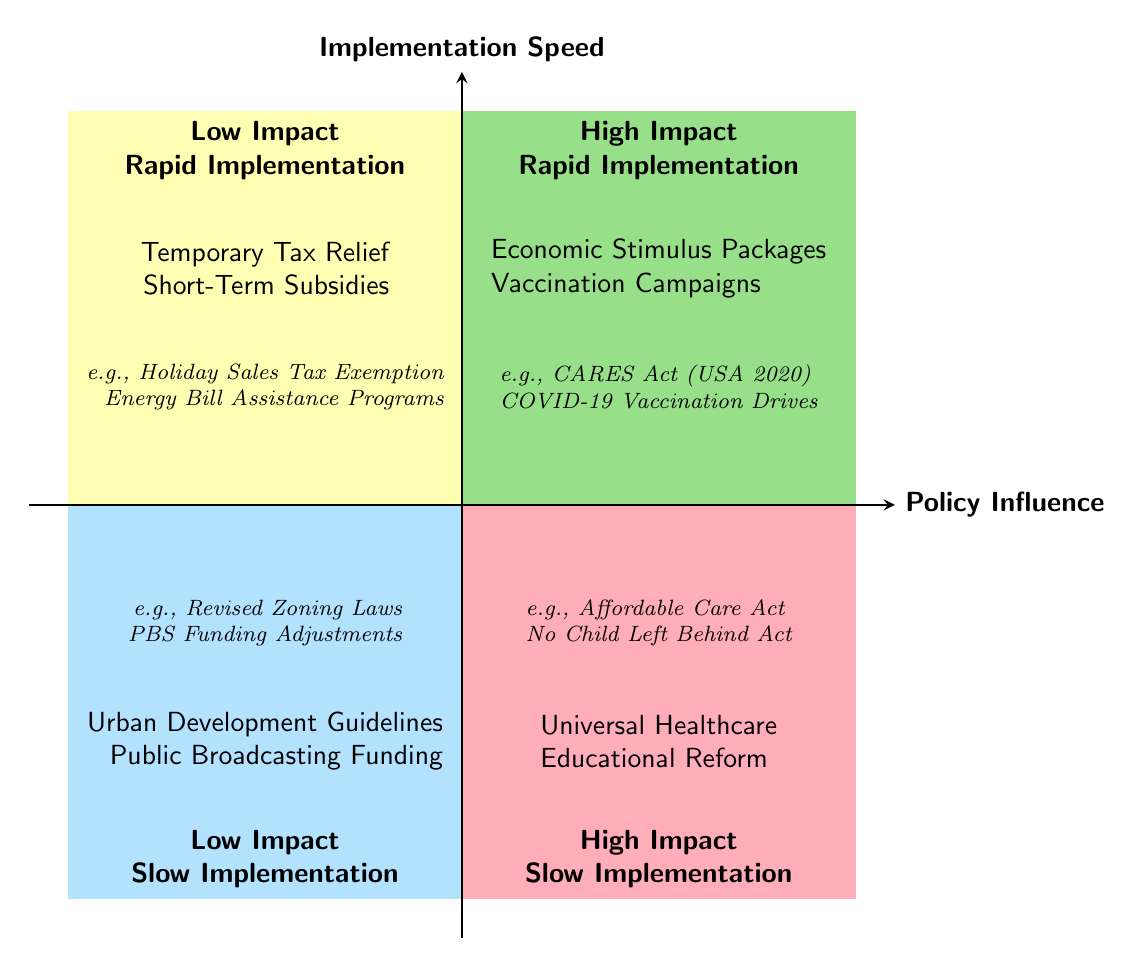What policies are in Quadrant 1? Quadrant 1 is labeled "High Impact, Rapid Implementation" and includes the policies Economic Stimulus Packages and Vaccination Campaigns.
Answer: Economic Stimulus Packages, Vaccination Campaigns Which quadrant has policies with low impact and rapid implementation? The quadrant labeled "Low Impact, Rapid Implementation" contains the policies Temporary Tax Relief and Short-Term Subsidies.
Answer: Low Impact, Rapid Implementation How many policies are in Quadrant 3? Quadrant 3 contains two policies: Universal Healthcare and Educational Reform. Thus, the total count is two.
Answer: 2 What is an example of a policy in Quadrant 4? Quadrant 4 is categorized as "Low Impact, Slow Implementation," featuring examples like Urban Development Guidelines.
Answer: Urban Development Guidelines Which policy has a high impact yet slow implementation? The policies listed in Quadrant 3, labeled "High Impact, Slow Implementation," include Universal Healthcare and Educational Reform. One specific policy is Universal Healthcare.
Answer: Universal Healthcare How does the speed of implementation compare between Quadrant 1 and Quadrant 3? Quadrant 1 showcases policies that are rapidly implemented, while Quadrant 3 features policies that are slowly implemented, highlighting a stark contrast in implementation speed.
Answer: Rapid vs. Slow Which example belongs to the vaccination campaigns policy? The example associated with Vaccination Campaigns in Quadrant 1 is the COVID-19 Vaccination Drives.
Answer: COVID-19 Vaccination Drives What type of policies are represented in Quadrant 2? Quadrant 2, labeled "Low Impact, Rapid Implementation," primarily showcases policies with minimal impact that can be implemented quickly.
Answer: Low Impact, Rapid Implementation What quadrant includes the Affordable Care Act? The Affordable Care Act is mentioned as an example under the policies in Quadrant 3, which is characterized by high impact and slow implementation.
Answer: Quadrant 3 